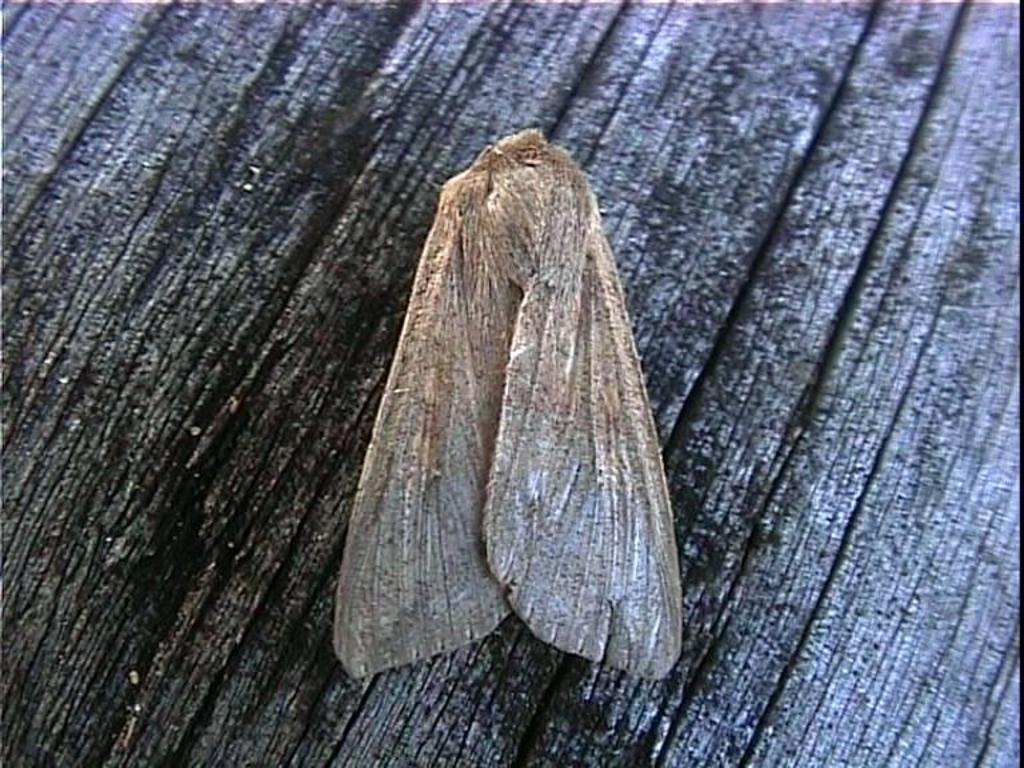What type of creature is present in the image? There is an insect in the image. Where is the insect located? The insect is on a wooden platform. What is the date of the insect's birth, as indicated on the calendar in the image? There is no calendar present in the image, so it is not possible to determine the insect's birth date. 